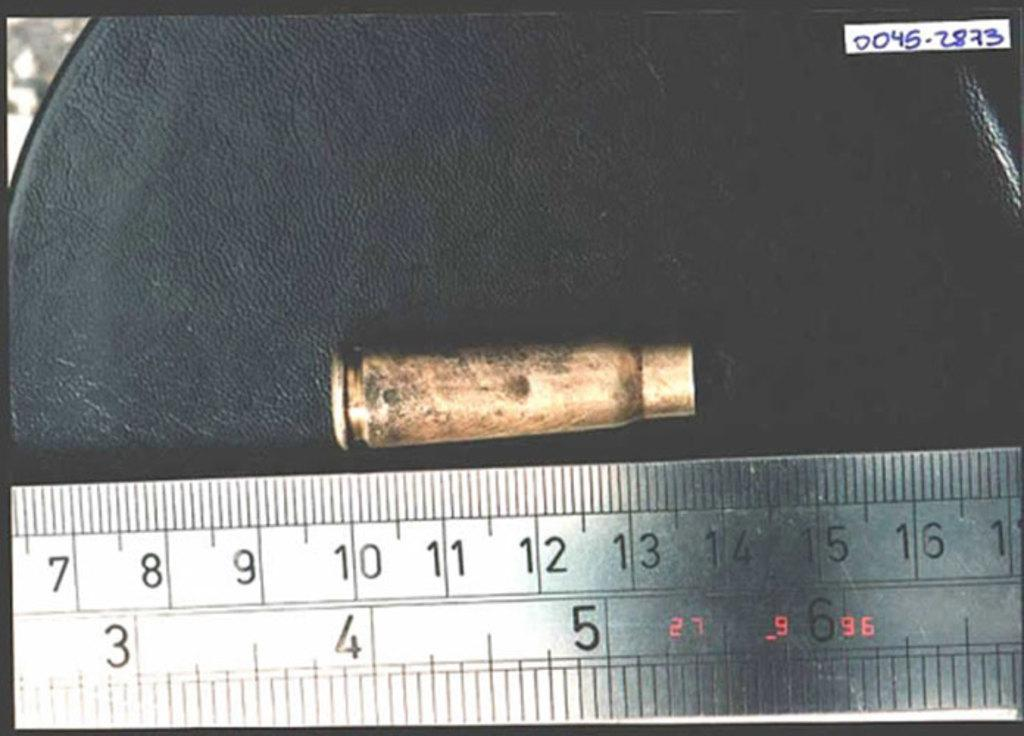<image>
Write a terse but informative summary of the picture. a metallic ruler that measures in inches and centimeters is measuring a bullet casing. 